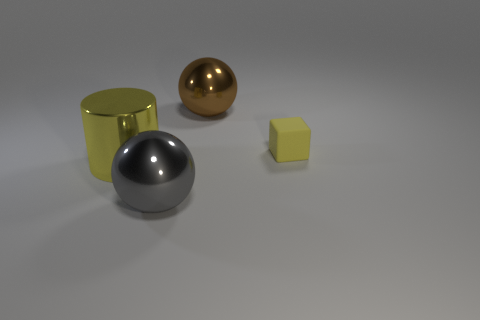Add 2 big gray balls. How many objects exist? 6 Subtract all brown balls. How many balls are left? 1 Subtract 1 spheres. How many spheres are left? 1 Subtract 0 purple spheres. How many objects are left? 4 Subtract all blocks. How many objects are left? 3 Subtract all green cubes. Subtract all yellow cylinders. How many cubes are left? 1 Subtract all yellow metallic objects. Subtract all tiny objects. How many objects are left? 2 Add 2 small rubber things. How many small rubber things are left? 3 Add 1 red metallic cubes. How many red metallic cubes exist? 1 